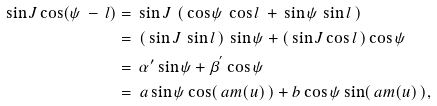<formula> <loc_0><loc_0><loc_500><loc_500>\sin J \cos ( \psi \, - \, l ) & = \, \sin J \, \left ( \, \cos \psi \, \cos l \, + \, \sin \psi \, \sin l \, \right ) \\ & = \, \left ( \, \sin J \, \sin l \, \right ) \, \sin \psi + \left ( \, \sin J \cos l \, \right ) \cos \psi \\ & = \, { \alpha } ^ { \prime } \sin \psi + { \beta } ^ { ^ { \prime } } \cos \psi \\ & = \, a \sin \psi \cos ( \, a m ( u ) \, ) + b \cos \psi \sin ( \, a m ( u ) \, ) ,</formula> 